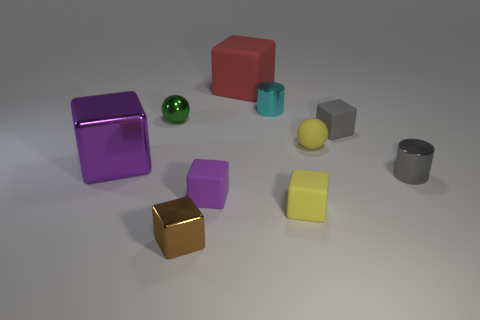Is the number of big rubber objects that are in front of the gray shiny cylinder less than the number of blocks?
Your answer should be very brief. Yes. There is a small sphere on the right side of the small purple block left of the ball on the right side of the tiny brown cube; what color is it?
Keep it short and to the point. Yellow. Is there any other thing that is the same material as the red block?
Keep it short and to the point. Yes. The other yellow object that is the same shape as the large rubber thing is what size?
Make the answer very short. Small. Is the number of small shiny things that are to the right of the gray metal thing less than the number of purple blocks on the left side of the small metallic sphere?
Your answer should be compact. Yes. What shape is the object that is to the right of the big purple cube and to the left of the tiny brown metallic block?
Your response must be concise. Sphere. What size is the purple thing that is made of the same material as the big red cube?
Your response must be concise. Small. Do the tiny shiny cube and the small ball left of the big red rubber block have the same color?
Keep it short and to the point. No. There is a small cube that is both on the left side of the large matte thing and behind the small metallic cube; what material is it made of?
Your answer should be very brief. Rubber. The rubber cube that is the same color as the matte sphere is what size?
Offer a terse response. Small. 